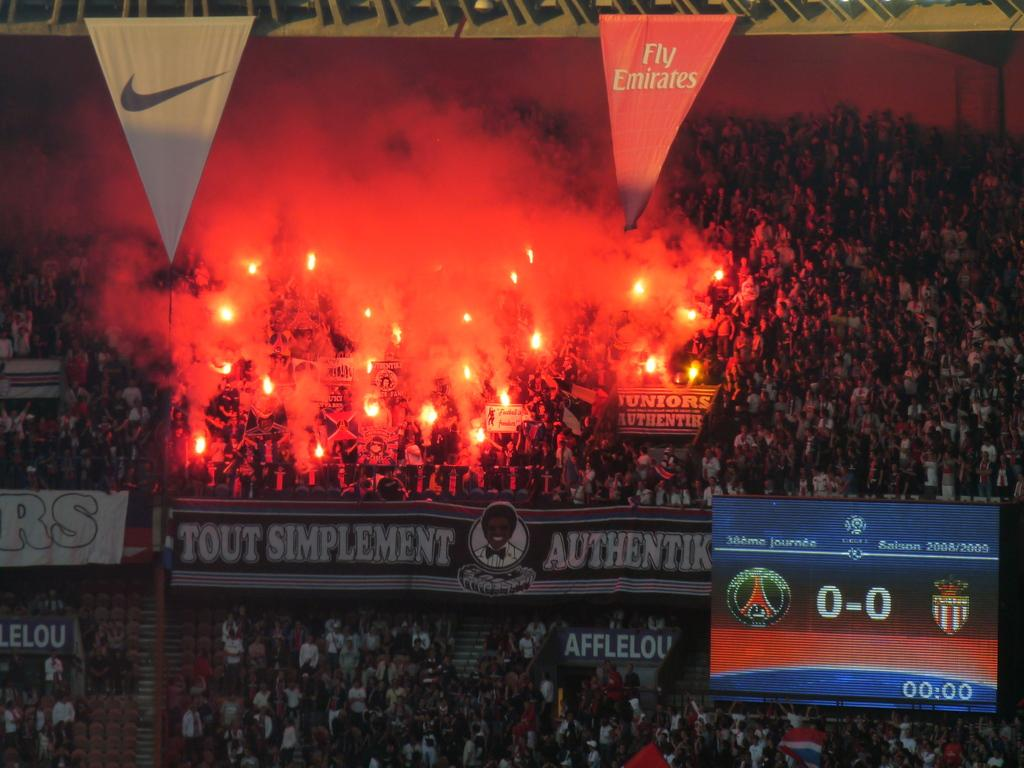<image>
Provide a brief description of the given image. The score in the lower right corner shows 0-0. 